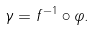Convert formula to latex. <formula><loc_0><loc_0><loc_500><loc_500>\gamma = f ^ { - 1 } \circ \varphi .</formula> 